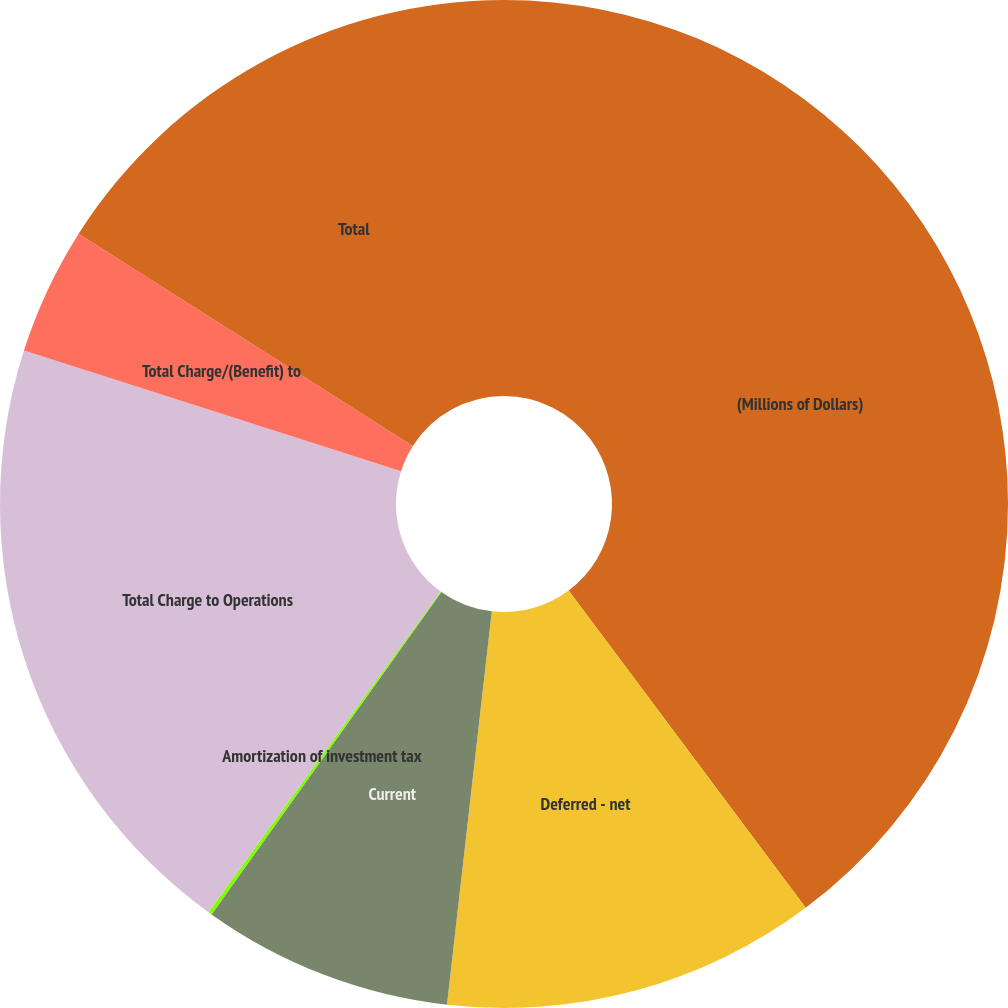Convert chart. <chart><loc_0><loc_0><loc_500><loc_500><pie_chart><fcel>(Millions of Dollars)<fcel>Deferred - net<fcel>Current<fcel>Amortization of investment tax<fcel>Total Charge to Operations<fcel>Total Charge/(Benefit) to<fcel>Total<nl><fcel>39.79%<fcel>12.02%<fcel>8.05%<fcel>0.12%<fcel>19.95%<fcel>4.09%<fcel>15.99%<nl></chart> 